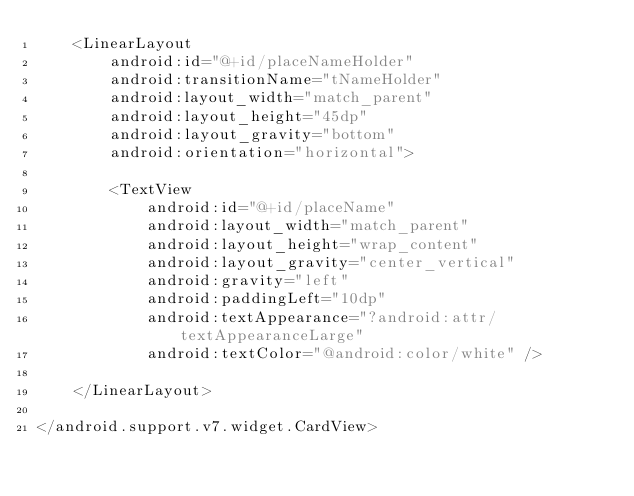<code> <loc_0><loc_0><loc_500><loc_500><_XML_>    <LinearLayout
        android:id="@+id/placeNameHolder"
        android:transitionName="tNameHolder"
        android:layout_width="match_parent"
        android:layout_height="45dp"
        android:layout_gravity="bottom"
        android:orientation="horizontal">

        <TextView
            android:id="@+id/placeName"
            android:layout_width="match_parent"
            android:layout_height="wrap_content"
            android:layout_gravity="center_vertical"
            android:gravity="left"
            android:paddingLeft="10dp"
            android:textAppearance="?android:attr/textAppearanceLarge"
            android:textColor="@android:color/white" />

    </LinearLayout>

</android.support.v7.widget.CardView></code> 